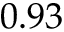Convert formula to latex. <formula><loc_0><loc_0><loc_500><loc_500>0 . 9 3</formula> 